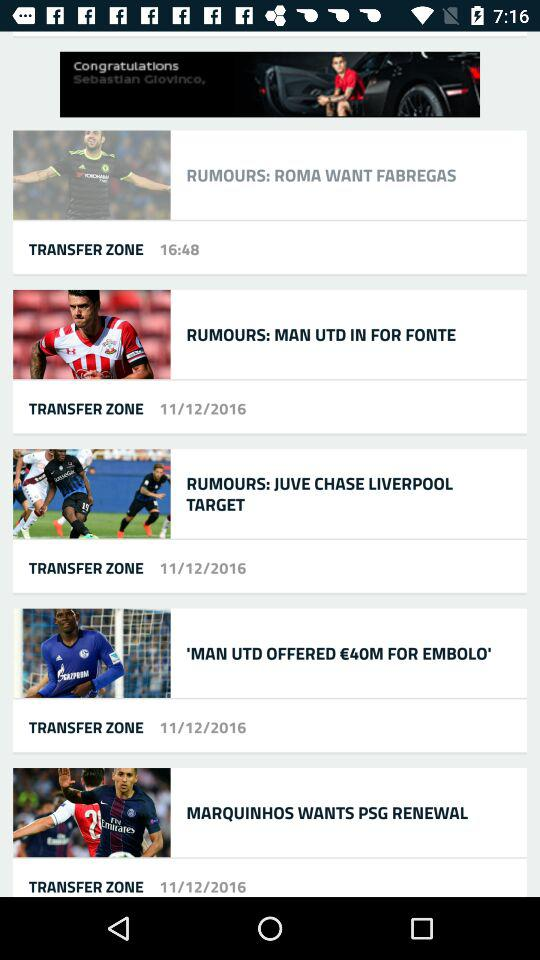On what date was the post "RUMOURS: MAN UTD IN FOR FONTE" updated? The post "RUMOURS: MAN UTD IN FOR FONTE" was updated on November 12, 2016. 